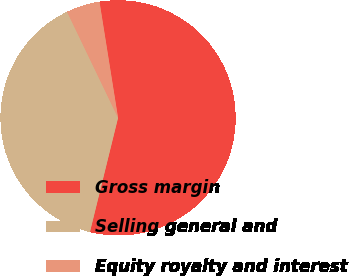Convert chart to OTSL. <chart><loc_0><loc_0><loc_500><loc_500><pie_chart><fcel>Gross margin<fcel>Selling general and<fcel>Equity royalty and interest<nl><fcel>56.37%<fcel>39.02%<fcel>4.61%<nl></chart> 